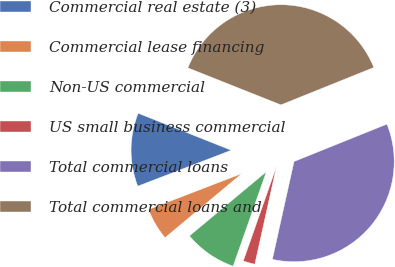Convert chart to OTSL. <chart><loc_0><loc_0><loc_500><loc_500><pie_chart><fcel>Commercial real estate (3)<fcel>Commercial lease financing<fcel>Non-US commercial<fcel>US small business commercial<fcel>Total commercial loans<fcel>Total commercial loans and<nl><fcel>11.87%<fcel>5.23%<fcel>8.55%<fcel>1.91%<fcel>34.57%<fcel>37.89%<nl></chart> 